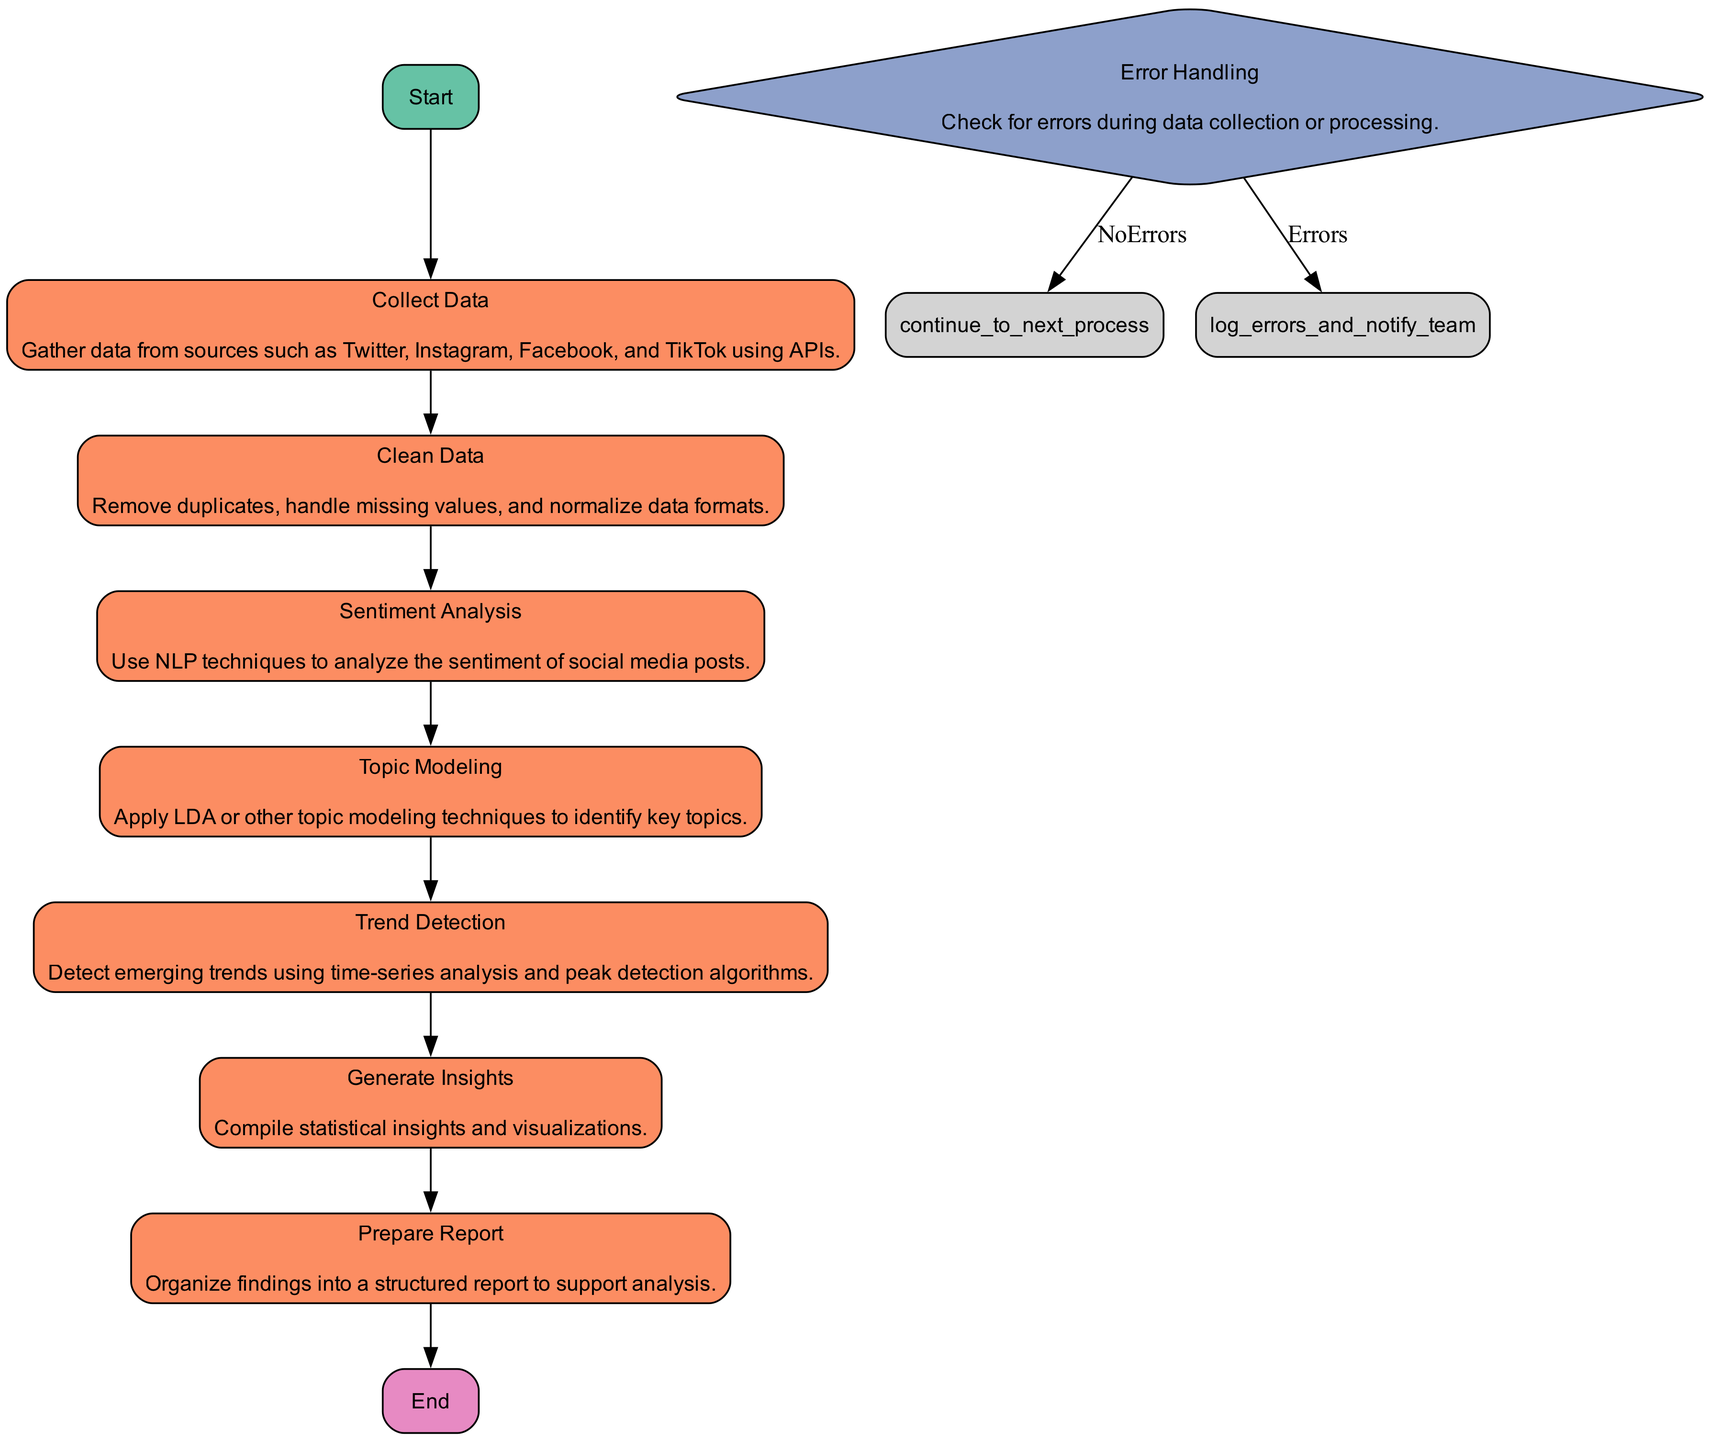What is the starting process in the diagram? The start of the flowchart is indicated by the "Start" node, which is the preliminary stage of the analysis strategy.
Answer: Start How many processes are there in total? By counting the nodes categorized as 'process' and including "Collect Data", "Clean Data", "Sentiment Analysis", "Topic Modeling", "Trend Detection", and "Generate Insights", there are six processes in total.
Answer: 6 What comes after the "Clean Data" step? Following the "Clean Data" node, the next step in the flowchart is "Sentiment Analysis", indicating the order of operations in the analysis process.
Answer: Sentiment Analysis What happens if there are errors during data collection or processing? According to the "Error Handling" decision node, if there are errors, the flowchart dictates to "Log errors and notify team," indicating that corrective action is necessary.
Answer: Log errors and notify team Which node generates insights? The "Generate Insights" node explicitly states that it compiles statistical insights and visualizations, making it clear which step is responsible for this outcome within the flowchart.
Answer: Generate Insights Which process immediately follows "Trend Detection"? The process that comes after "Trend Detection" is "Generate Insights", which shows the sequential relationship between detecting trends and compiling insights based on them.
Answer: Generate Insights What type of node is "Error Handling"? "Error Handling" is classified as a decision node in the flowchart, which is used to determine the path to take based on the presence or absence of errors during prior processing steps.
Answer: Decision How does the flowchart conclude? The flowchart concludes with the "End" node, signaling the completion of the social media trend analysis strategy after all necessary processes have been performed.
Answer: End 